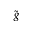Convert formula to latex. <formula><loc_0><loc_0><loc_500><loc_500>\tilde { g }</formula> 